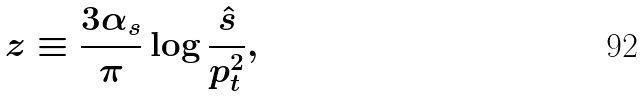Convert formula to latex. <formula><loc_0><loc_0><loc_500><loc_500>z \equiv \frac { 3 \alpha _ { s } } { \pi } \log \frac { \hat { s } } { p _ { t } ^ { 2 } } ,</formula> 